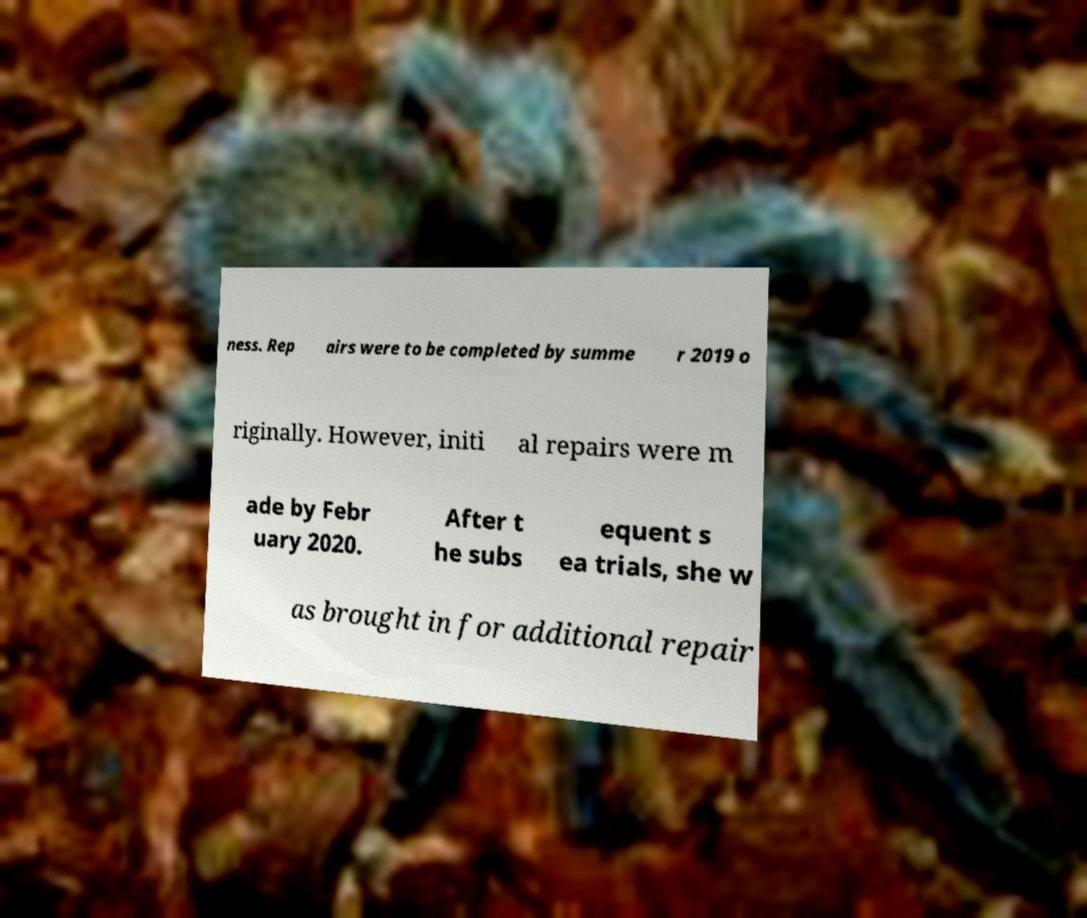Could you assist in decoding the text presented in this image and type it out clearly? ness. Rep airs were to be completed by summe r 2019 o riginally. However, initi al repairs were m ade by Febr uary 2020. After t he subs equent s ea trials, she w as brought in for additional repair 